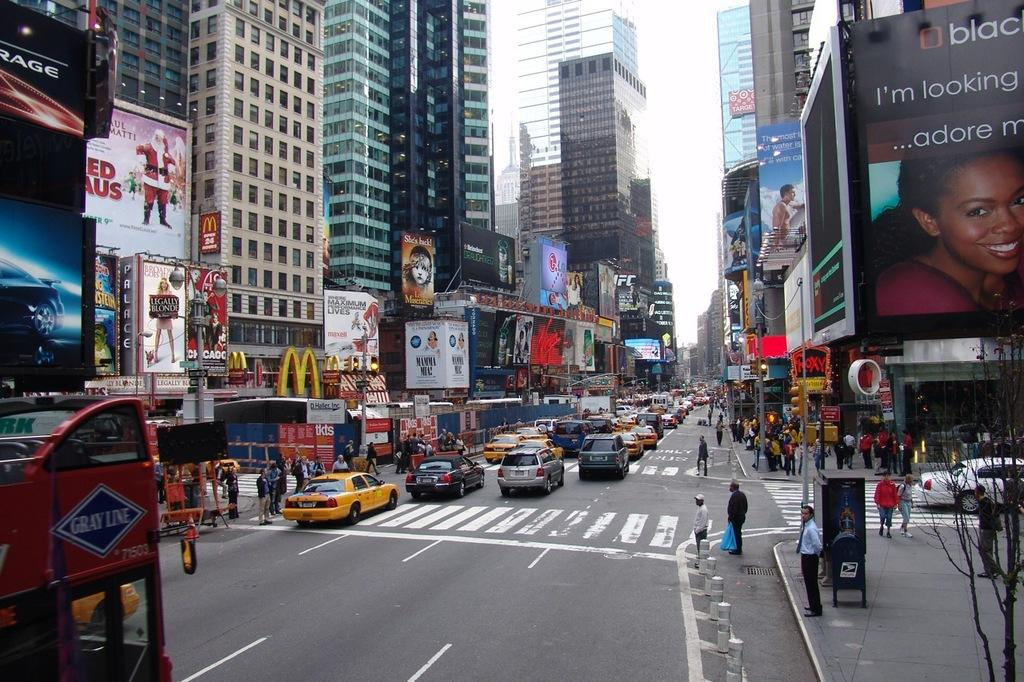<image>
Create a compact narrative representing the image presented. Busy New York street with a Grey Line bus on the left. 